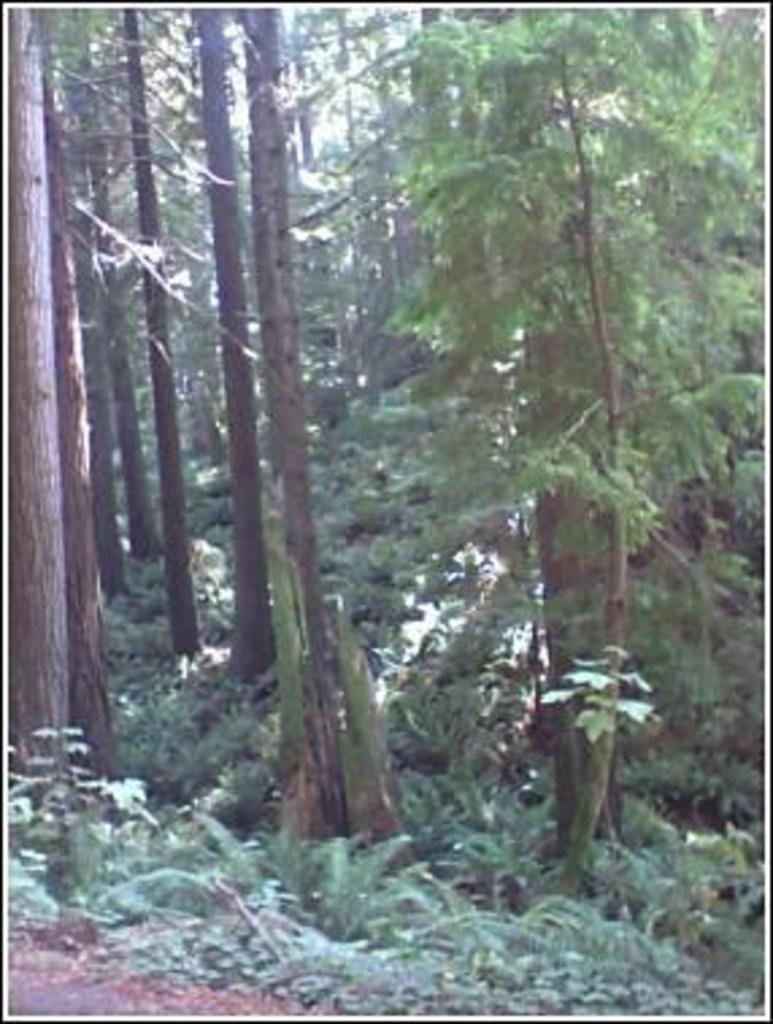How would you summarize this image in a sentence or two? In this image it seems like a forest in which there are so many tall trees. At the bottom there are small plants and sand. 